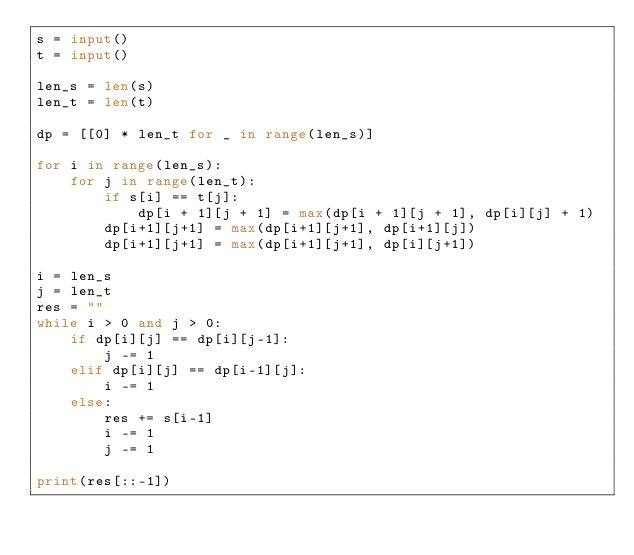Convert code to text. <code><loc_0><loc_0><loc_500><loc_500><_Python_>s = input()
t = input()

len_s = len(s)
len_t = len(t)

dp = [[0] * len_t for _ in range(len_s)]

for i in range(len_s):
    for j in range(len_t):
        if s[i] == t[j]:
            dp[i + 1][j + 1] = max(dp[i + 1][j + 1], dp[i][j] + 1)
        dp[i+1][j+1] = max(dp[i+1][j+1], dp[i+1][j])
        dp[i+1][j+1] = max(dp[i+1][j+1], dp[i][j+1])

i = len_s
j = len_t
res = ""
while i > 0 and j > 0:
    if dp[i][j] == dp[i][j-1]:
        j -= 1
    elif dp[i][j] == dp[i-1][j]:
        i -= 1
    else:
        res += s[i-1]
        i -= 1
        j -= 1

print(res[::-1])
</code> 